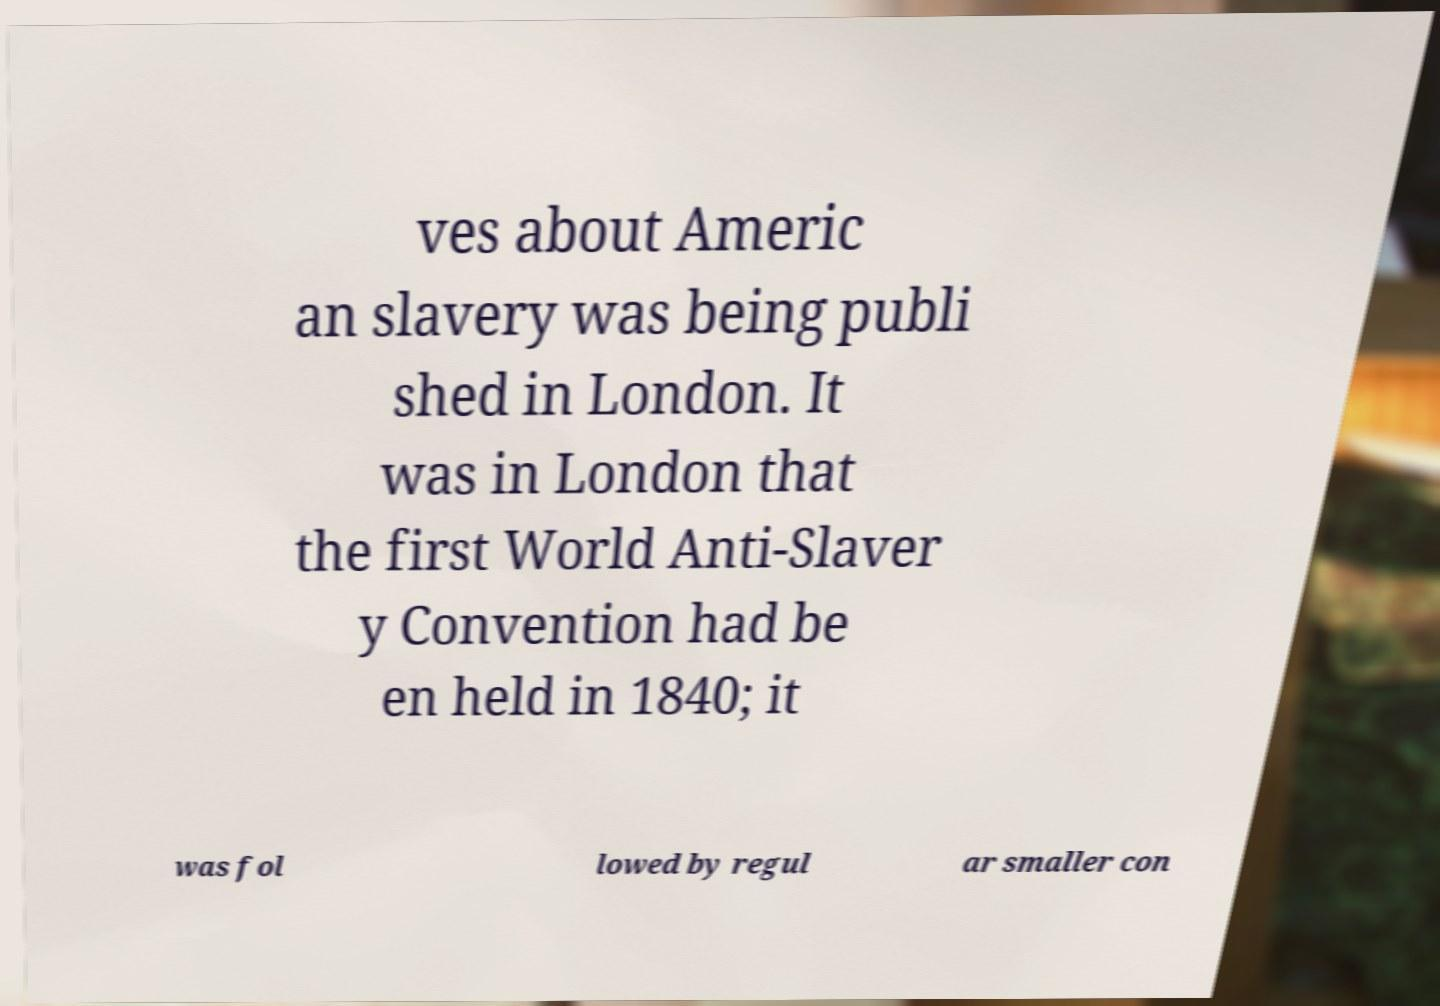There's text embedded in this image that I need extracted. Can you transcribe it verbatim? ves about Americ an slavery was being publi shed in London. It was in London that the first World Anti-Slaver y Convention had be en held in 1840; it was fol lowed by regul ar smaller con 